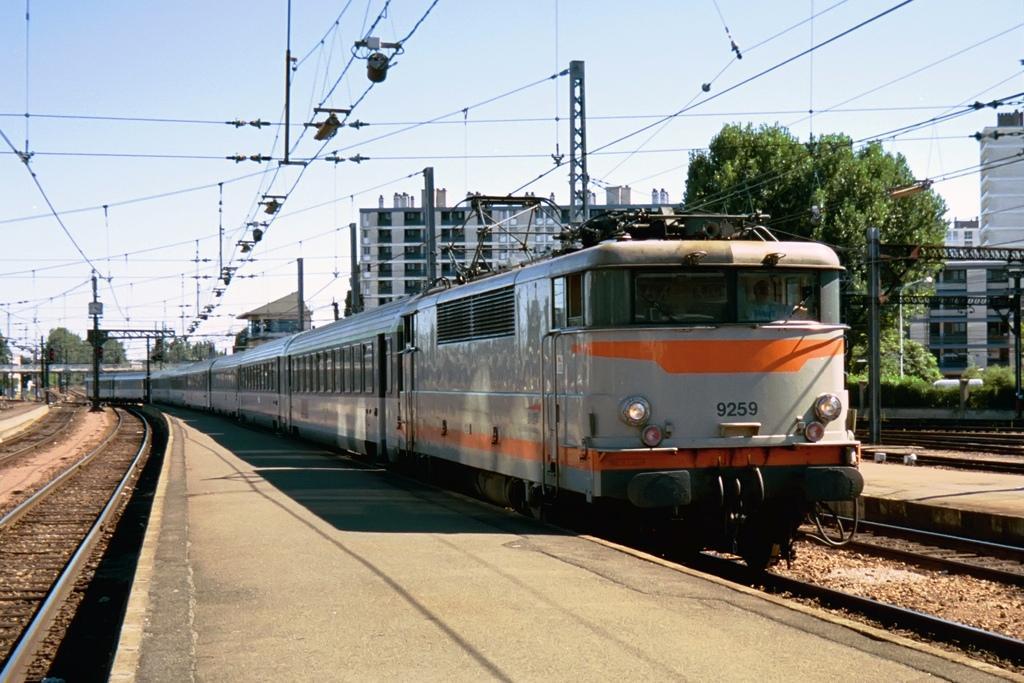Could you give a brief overview of what you see in this image? As we can see in the image there is a train, railway track, plants, trees, buildings and sky. 